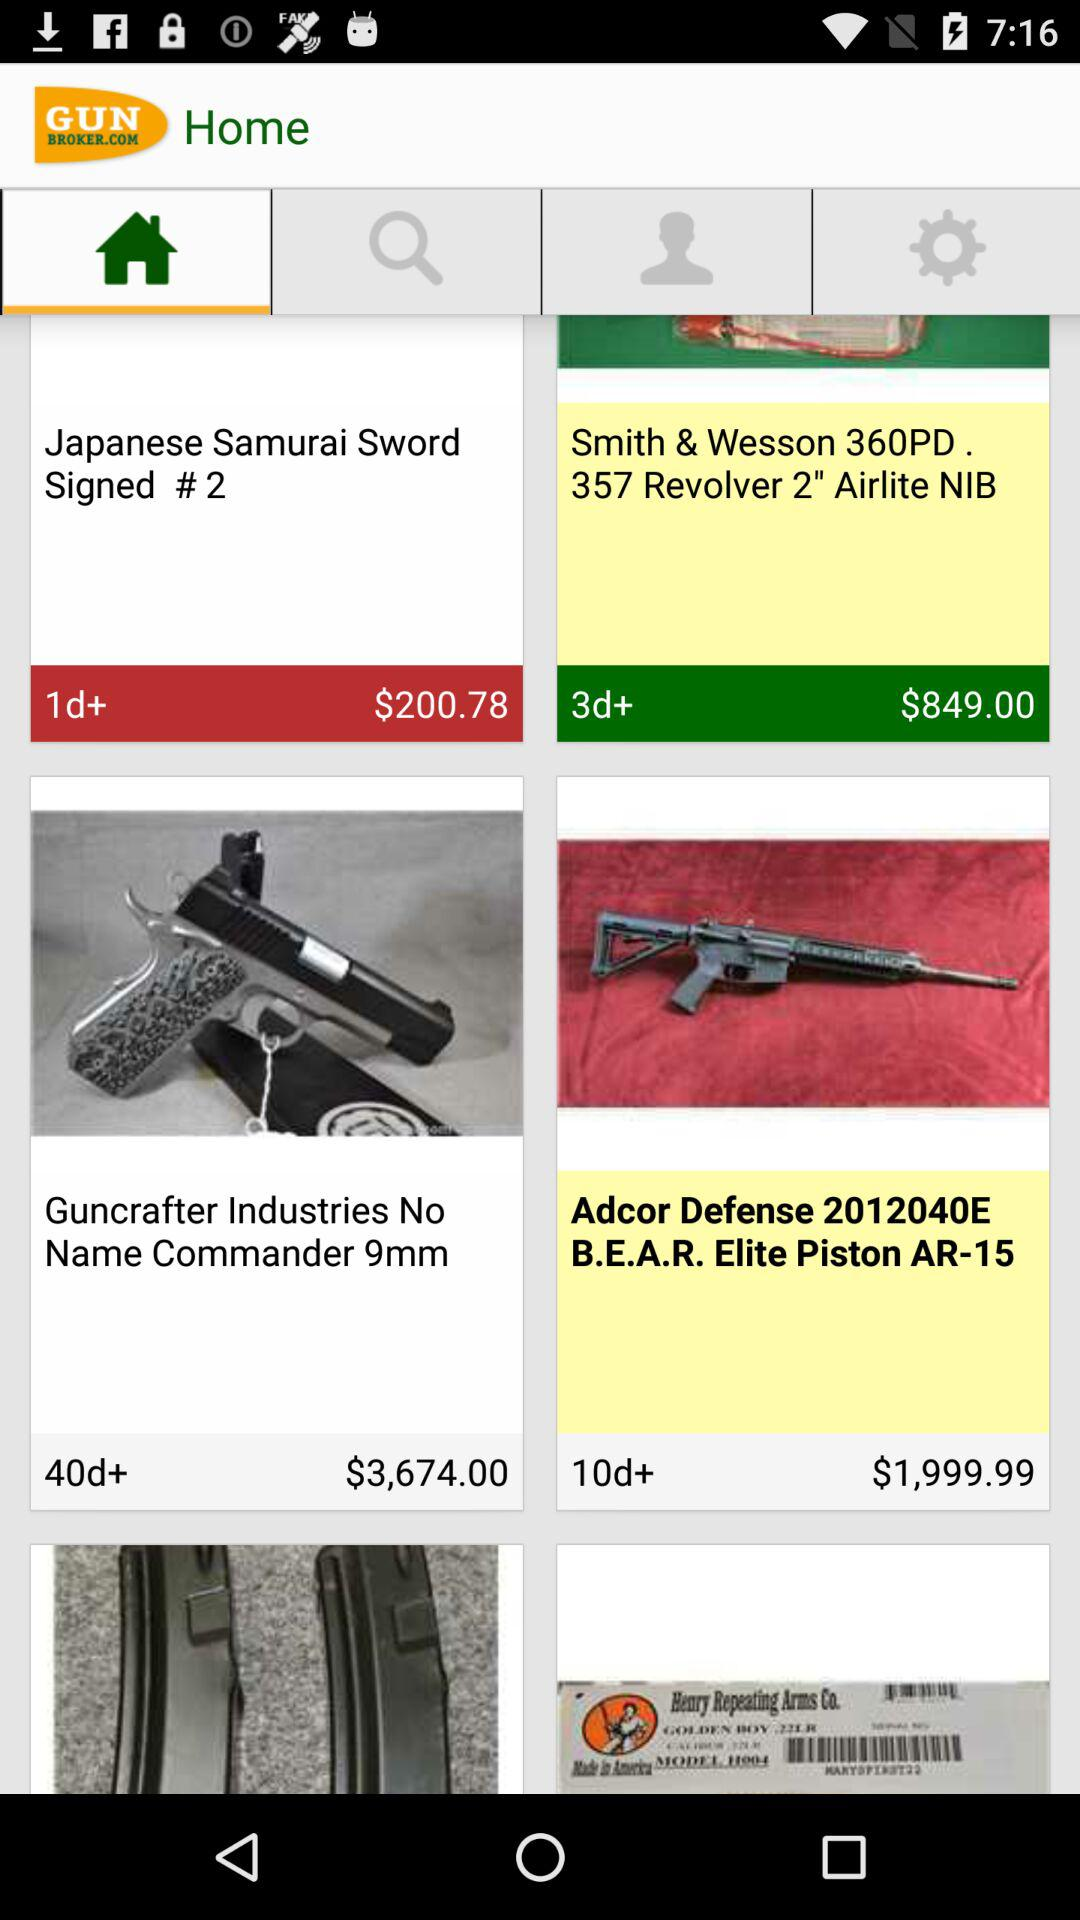What is the price of "Commander 9mm"? The price is $3,674. 